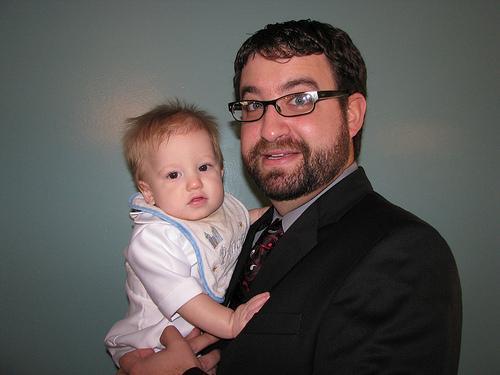How many men are there?
Give a very brief answer. 1. 